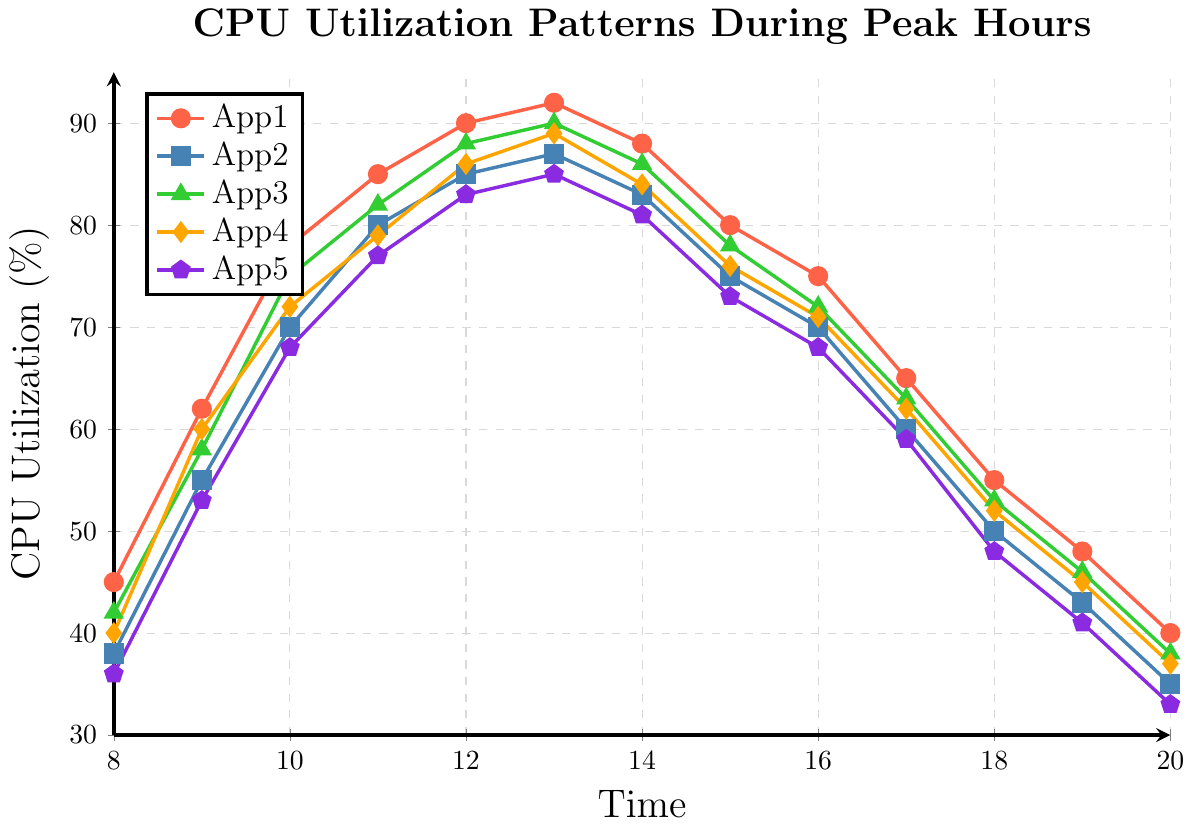What is the highest CPU utilization recorded for App1? The highest point on the line corresponding to App1 (red) is at 13:00 with a utilization of 92%.
Answer: 92% At what time did App2 reach its peak CPU utilization? By tracking the line for App2 (blue), the peak is seen at 13:00 with a utilization of 87%.
Answer: 13:00 How much did the CPU utilization for App3 decrease from 13:00 to 20:00? The utilization at 13:00 is 90% and at 20:00 it is 38%. The decrease is 90% - 38% = 52%.
Answer: 52% Which application had the lowest CPU utilization at 08:00? At 08:00, the utilizations are App1: 45%, App2: 38%, App3: 42%, App4: 40%, App5: 36%. The lowest is App5 with 36%.
Answer: App5 Between 14:00 and 16:00, which application saw the greatest decrease in CPU utilization? Calculate the differences: App1 (88%-75%=13%), App2 (83%-70%=13%), App3 (86%-72%=14%), App4 (84%-71%=13%), App5 (81%-68%=13%). App3 saw the greatest decrease of 14%.
Answer: App3 What is the average CPU utilization for App4 between 08:00 and 12:00? Sum the values for App4 at 08:00 (40%), 09:00 (60%), 10:00 (72%), 11:00 (79%), and 12:00 (86%), then divide by 5: (40+60+72+79+86)/5 = 67.4%.
Answer: 67.4% Compare the CPU utilization of App2 and App5 at 17:00. Which one is higher and by how much? At 17:00, App2 has 60% and App5 has 59%. App2 is higher by 60% - 59% = 1%.
Answer: App2, 1% At what time do all applications show decreasing CPU utilization trends from the previous hour? Look at the trends: Between 13:00 and 14:00 all apps start decreasing and continue until 20:00. The time is 14:00.
Answer: 14:00 What color represents App5, and what is its CPU utilization at 18:00? The color representing App5 is purple, and at 18:00, its CPU utilization is shown as 48%.
Answer: Purple, 48% 